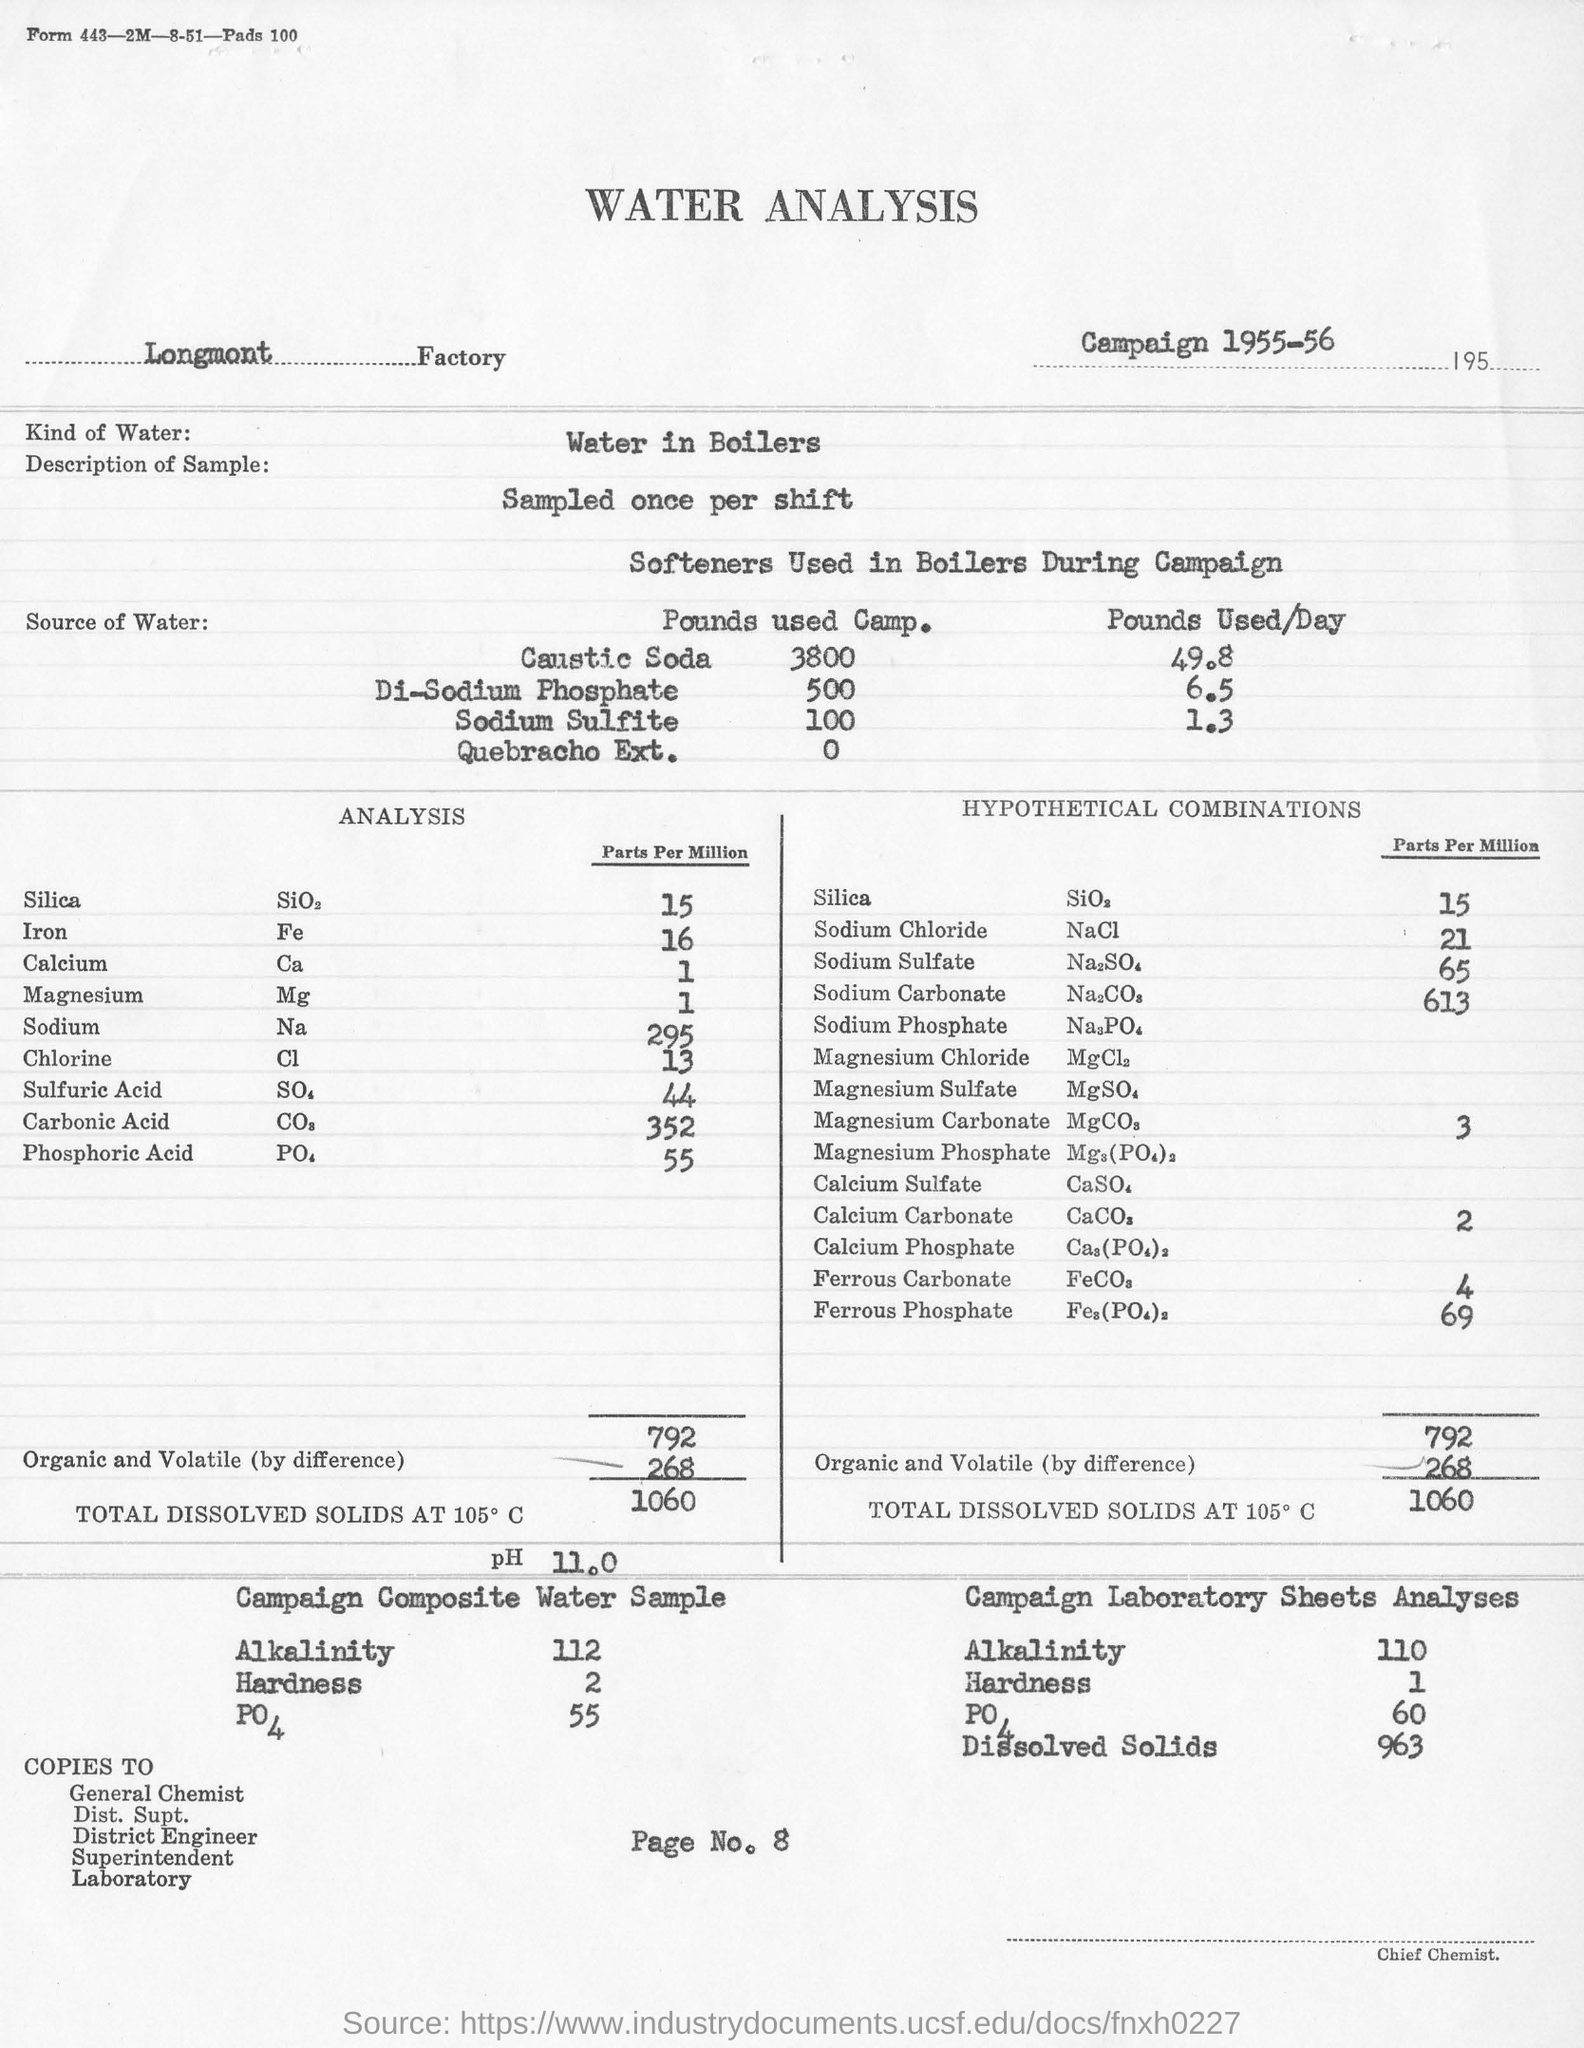Point out several critical features in this image. The pH of the Campaign Composite Water Sample is 11.2, indicating that it is highly alkaline. The analysis was conducted at the Longmont Factory. The concentration of sodium chloride in parts per million in the analysis is 21. The type of water used for analysis is typically water found in boilers. The hardness of a composite water sample from a campaign is 2. 